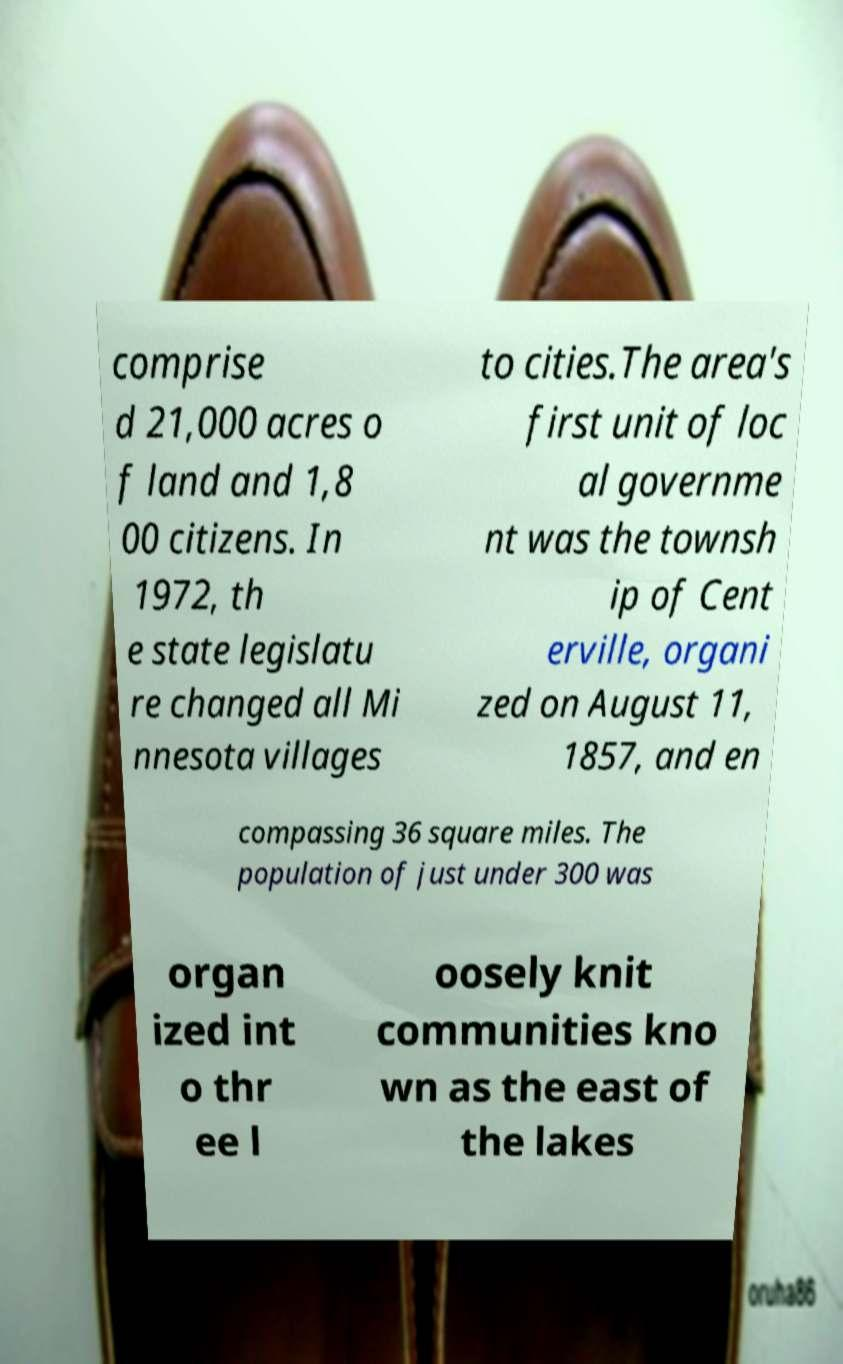Please read and relay the text visible in this image. What does it say? comprise d 21,000 acres o f land and 1,8 00 citizens. In 1972, th e state legislatu re changed all Mi nnesota villages to cities.The area's first unit of loc al governme nt was the townsh ip of Cent erville, organi zed on August 11, 1857, and en compassing 36 square miles. The population of just under 300 was organ ized int o thr ee l oosely knit communities kno wn as the east of the lakes 